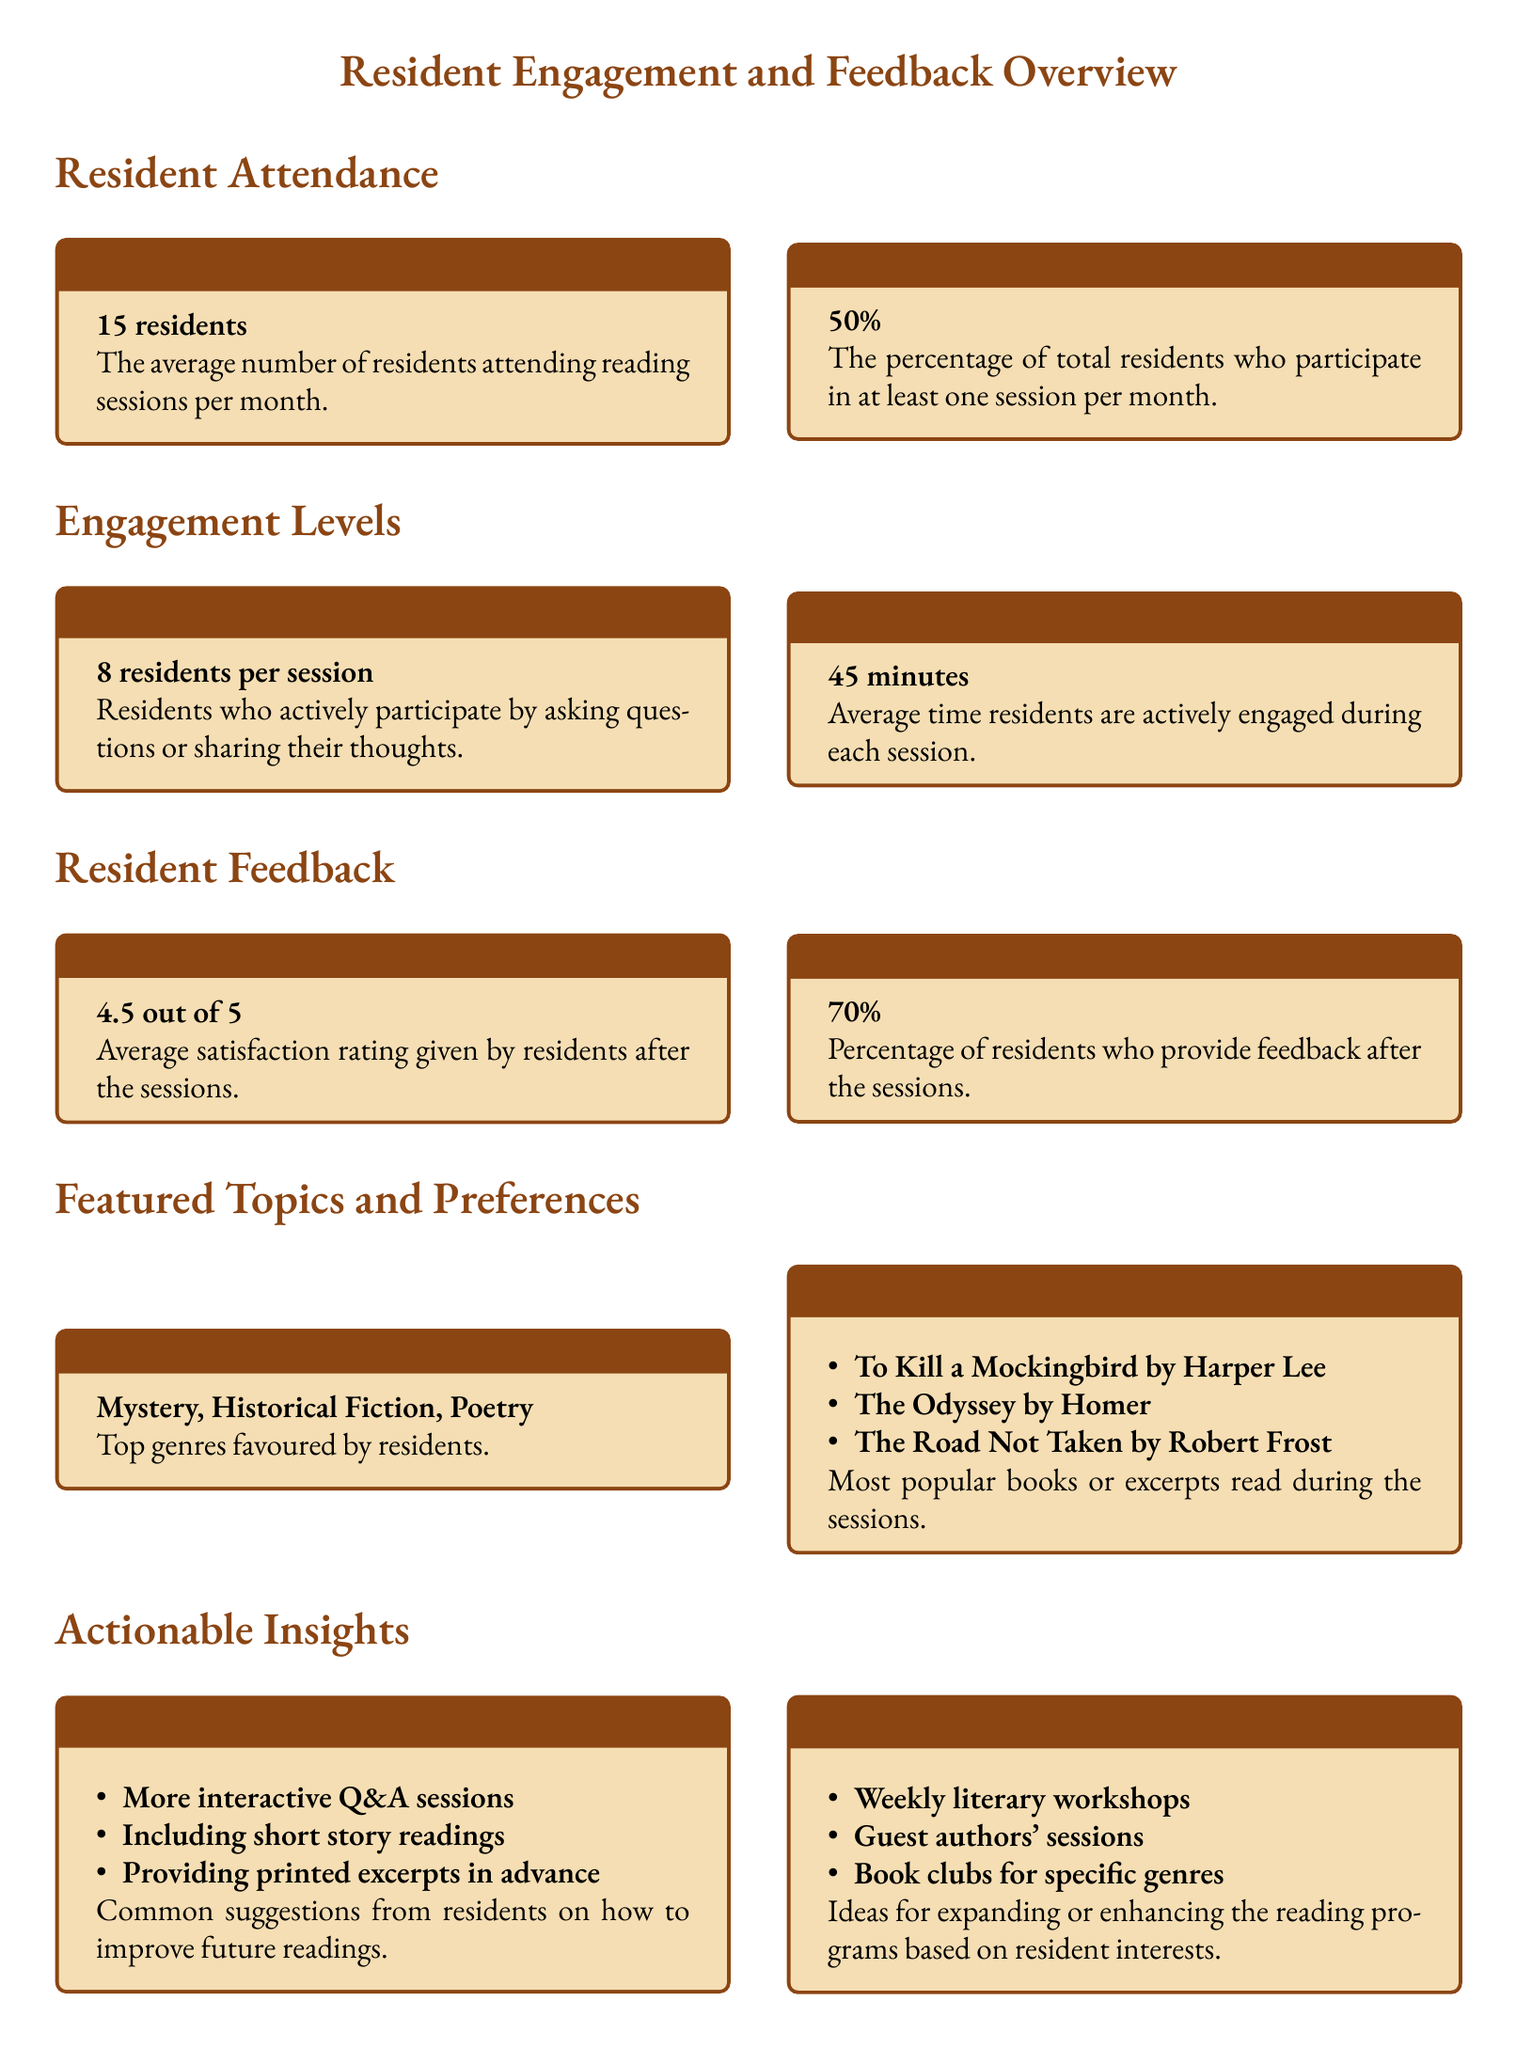What is the average attendance of residents per month? The average attendance is a specific metric mentioned in the document regarding the participation in reading sessions.
Answer: 15 residents What is the engagement duration during each session? Engagement duration indicates how long residents are actively involved, and it is explicitly stated in the document.
Answer: 45 minutes What is the satisfaction score given by residents? The satisfaction score is a summarized measure of residents' happiness with the sessions, as shown in the document.
Answer: 4.5 out of 5 What percentage of residents provide feedback after the sessions? The document states this percentage as an important measure of resident engagement.
Answer: 70% Which genres do residents prefer the most? The document lists specific genres favored by residents, making this a straightforward retrieval of information.
Answer: Mystery, Historical Fiction, Poetry How many residents actively participate by asking questions or sharing thoughts? This question requires synthesis of information about active engagement presented in the scorecard.
Answer: 8 residents per session What are some suggestions for improving the reading sessions? This question aggregates several ideas provided by the residents, requiring knowledge of their feedback.
Answer: More interactive Q&A sessions, Including short story readings, Providing printed excerpts in advance What ideas are proposed for expanding the reading programs? The document states potential expansions of the program based on resident interests, making it a document-specific inquiry.
Answer: Weekly literary workshops, Guest authors' sessions, Book clubs for specific genres 